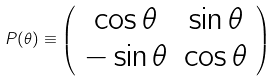<formula> <loc_0><loc_0><loc_500><loc_500>P ( \theta ) \equiv \left ( \begin{array} { c c } \cos \theta & \sin \theta \\ - \sin \theta & \cos \theta \end{array} \right )</formula> 